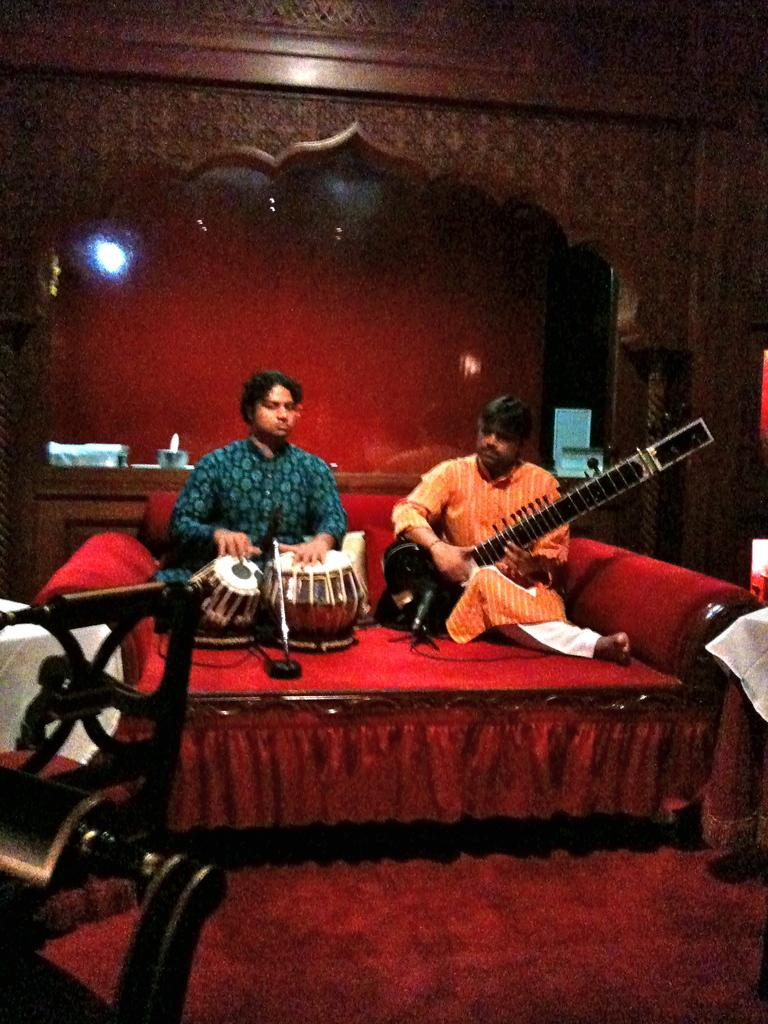How many people are in the image? There are two persons in the image. What are the two persons doing in the image? The two persons are sitting on a sofa and playing a musical instrument. What is the comparison between the two persons' expertise in playing the musical instrument? There is no information in the image to make a comparison between the two persons' expertise in playing the musical instrument. 